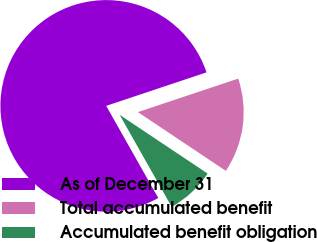<chart> <loc_0><loc_0><loc_500><loc_500><pie_chart><fcel>As of December 31<fcel>Total accumulated benefit<fcel>Accumulated benefit obligation<nl><fcel>78.05%<fcel>14.5%<fcel>7.44%<nl></chart> 